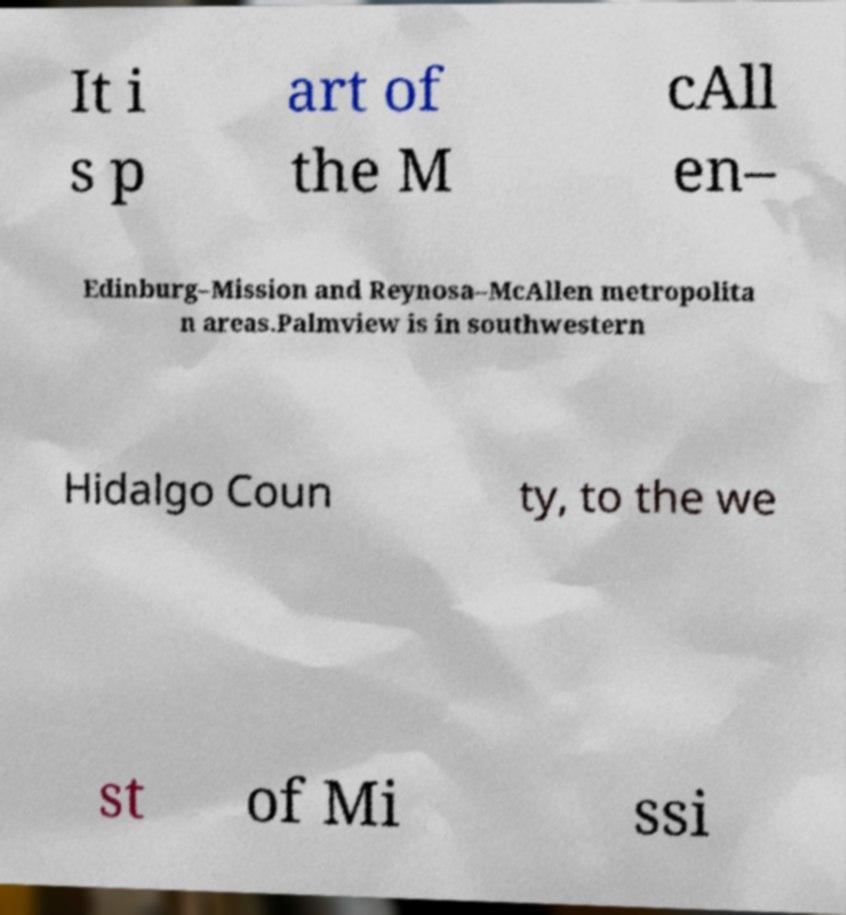Could you extract and type out the text from this image? It i s p art of the M cAll en– Edinburg–Mission and Reynosa–McAllen metropolita n areas.Palmview is in southwestern Hidalgo Coun ty, to the we st of Mi ssi 